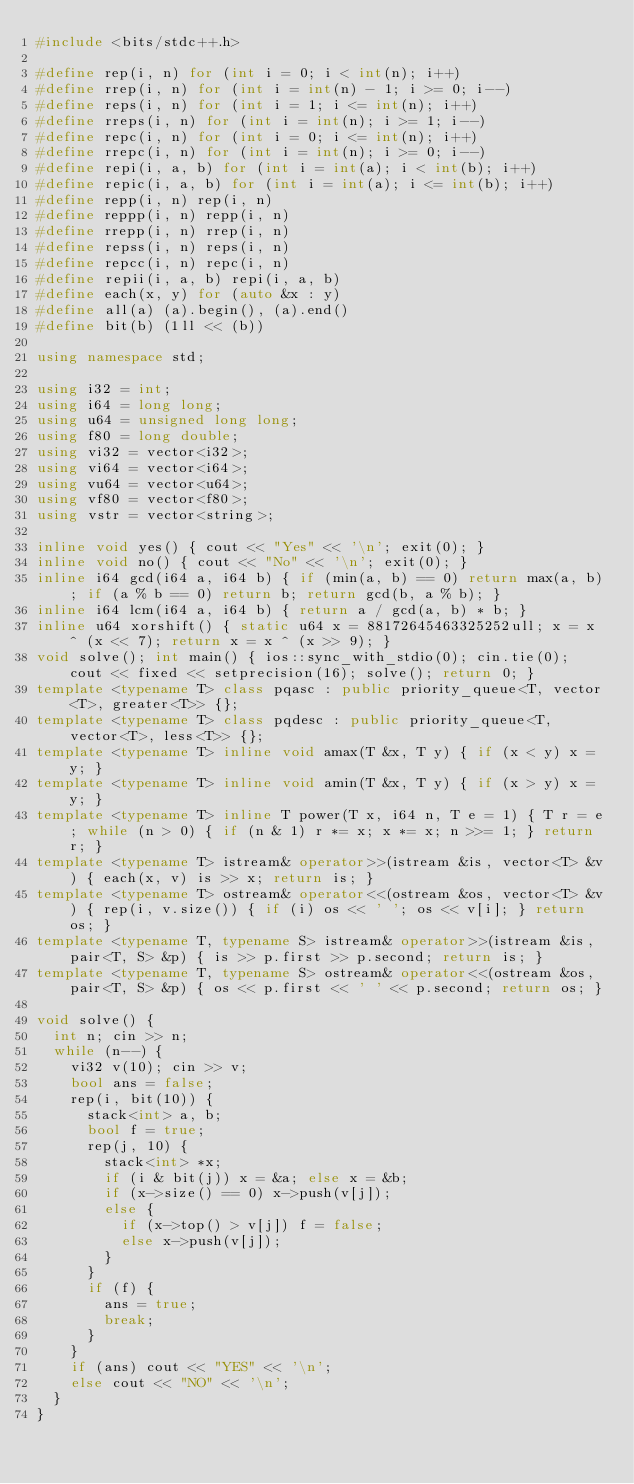<code> <loc_0><loc_0><loc_500><loc_500><_C++_>#include <bits/stdc++.h>

#define rep(i, n) for (int i = 0; i < int(n); i++)
#define rrep(i, n) for (int i = int(n) - 1; i >= 0; i--)
#define reps(i, n) for (int i = 1; i <= int(n); i++)
#define rreps(i, n) for (int i = int(n); i >= 1; i--)
#define repc(i, n) for (int i = 0; i <= int(n); i++)
#define rrepc(i, n) for (int i = int(n); i >= 0; i--)
#define repi(i, a, b) for (int i = int(a); i < int(b); i++)
#define repic(i, a, b) for (int i = int(a); i <= int(b); i++)
#define repp(i, n) rep(i, n)
#define reppp(i, n) repp(i, n)
#define rrepp(i, n) rrep(i, n)
#define repss(i, n) reps(i, n)
#define repcc(i, n) repc(i, n)
#define repii(i, a, b) repi(i, a, b)
#define each(x, y) for (auto &x : y)
#define all(a) (a).begin(), (a).end()
#define bit(b) (1ll << (b))

using namespace std;

using i32 = int;
using i64 = long long;
using u64 = unsigned long long;
using f80 = long double;
using vi32 = vector<i32>;
using vi64 = vector<i64>;
using vu64 = vector<u64>;
using vf80 = vector<f80>;
using vstr = vector<string>;

inline void yes() { cout << "Yes" << '\n'; exit(0); }
inline void no() { cout << "No" << '\n'; exit(0); }
inline i64 gcd(i64 a, i64 b) { if (min(a, b) == 0) return max(a, b); if (a % b == 0) return b; return gcd(b, a % b); }
inline i64 lcm(i64 a, i64 b) { return a / gcd(a, b) * b; }
inline u64 xorshift() { static u64 x = 88172645463325252ull; x = x ^ (x << 7); return x = x ^ (x >> 9); }
void solve(); int main() { ios::sync_with_stdio(0); cin.tie(0); cout << fixed << setprecision(16); solve(); return 0; }
template <typename T> class pqasc : public priority_queue<T, vector<T>, greater<T>> {};
template <typename T> class pqdesc : public priority_queue<T, vector<T>, less<T>> {};
template <typename T> inline void amax(T &x, T y) { if (x < y) x = y; }
template <typename T> inline void amin(T &x, T y) { if (x > y) x = y; }
template <typename T> inline T power(T x, i64 n, T e = 1) { T r = e; while (n > 0) { if (n & 1) r *= x; x *= x; n >>= 1; } return r; }
template <typename T> istream& operator>>(istream &is, vector<T> &v) { each(x, v) is >> x; return is; }
template <typename T> ostream& operator<<(ostream &os, vector<T> &v) { rep(i, v.size()) { if (i) os << ' '; os << v[i]; } return os; }
template <typename T, typename S> istream& operator>>(istream &is, pair<T, S> &p) { is >> p.first >> p.second; return is; }
template <typename T, typename S> ostream& operator<<(ostream &os, pair<T, S> &p) { os << p.first << ' ' << p.second; return os; }

void solve() {
  int n; cin >> n;
  while (n--) {
    vi32 v(10); cin >> v;
    bool ans = false;
    rep(i, bit(10)) {
      stack<int> a, b;
      bool f = true;
      rep(j, 10) {
        stack<int> *x;
        if (i & bit(j)) x = &a; else x = &b;
        if (x->size() == 0) x->push(v[j]);
        else {
          if (x->top() > v[j]) f = false;
          else x->push(v[j]);
        }
      }
      if (f) {
        ans = true;
        break;
      }
    }
    if (ans) cout << "YES" << '\n';
    else cout << "NO" << '\n';
  }
}

</code> 